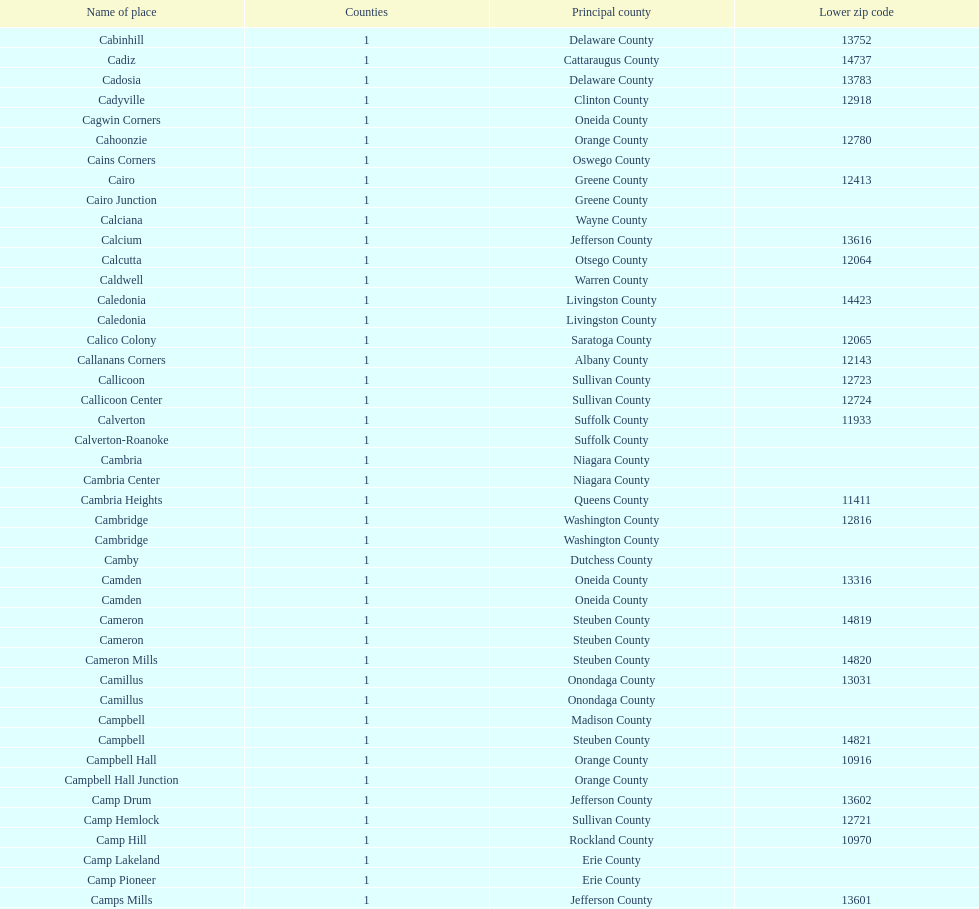How many total places are in greene county? 10. 